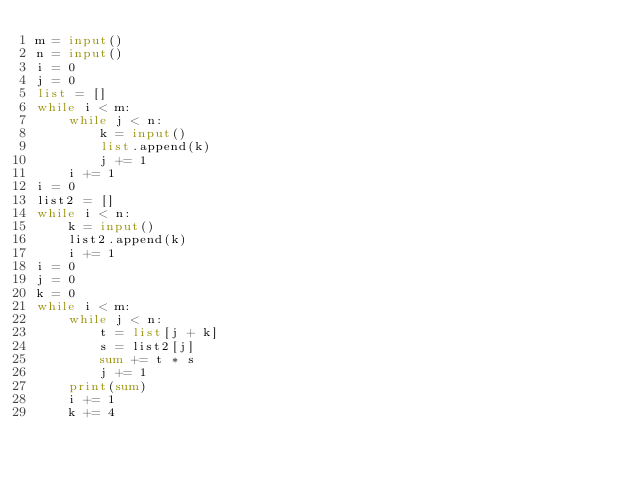Convert code to text. <code><loc_0><loc_0><loc_500><loc_500><_Python_>m = input()
n = input()
i = 0
j = 0
list = []
while i < m:
    while j < n:
        k = input()
        list.append(k)
        j += 1
    i += 1
i = 0
list2 = []
while i < n:
    k = input()
    list2.append(k)
    i += 1
i = 0
j = 0
k = 0
while i < m:
    while j < n:
        t = list[j + k]
        s = list2[j]
        sum += t * s
        j += 1
    print(sum)
    i += 1
    k += 4</code> 